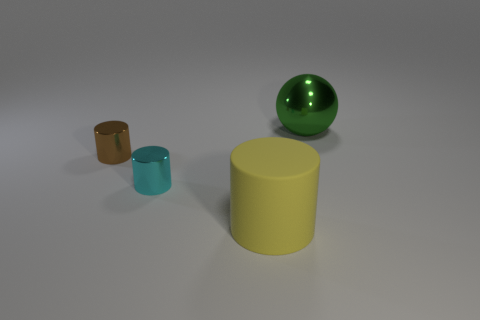Add 3 large green shiny objects. How many objects exist? 7 Subtract all cyan cylinders. How many cylinders are left? 2 Subtract 1 spheres. How many spheres are left? 0 Subtract all yellow cylinders. How many cylinders are left? 2 Subtract all small brown metal cylinders. Subtract all brown shiny cylinders. How many objects are left? 2 Add 3 green objects. How many green objects are left? 4 Add 1 large purple rubber blocks. How many large purple rubber blocks exist? 1 Subtract 0 green cylinders. How many objects are left? 4 Subtract all cylinders. How many objects are left? 1 Subtract all purple cylinders. Subtract all green cubes. How many cylinders are left? 3 